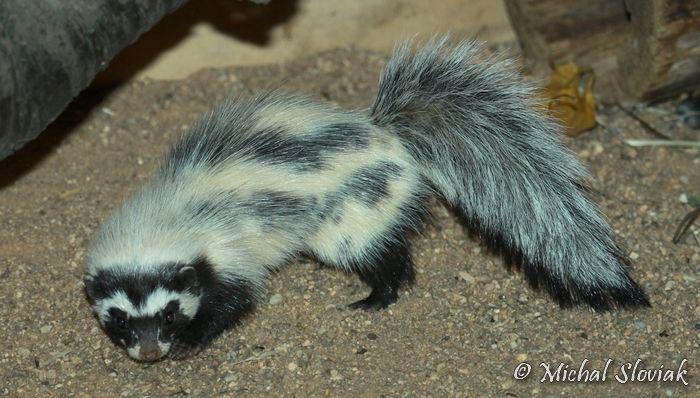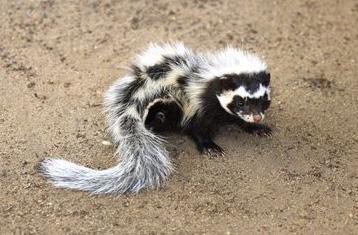The first image is the image on the left, the second image is the image on the right. For the images displayed, is the sentence "Both skunks are pointed in the same direction." factually correct? Answer yes or no. No. 